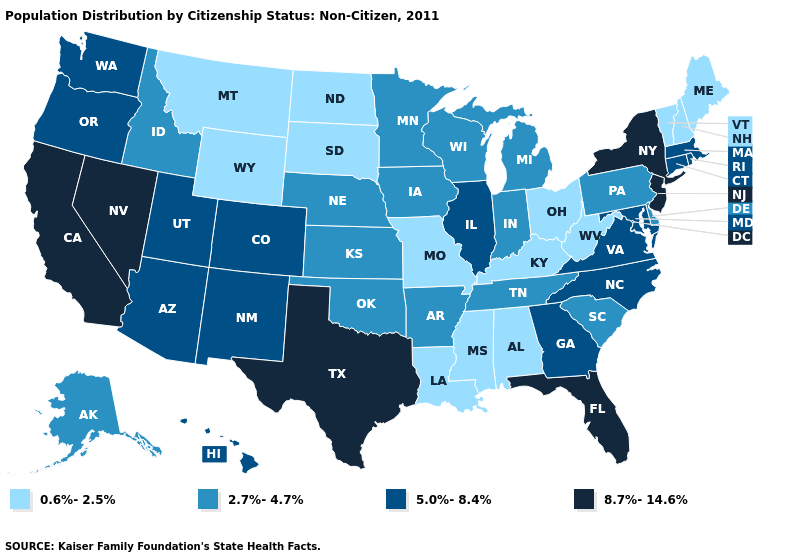Name the states that have a value in the range 5.0%-8.4%?
Quick response, please. Arizona, Colorado, Connecticut, Georgia, Hawaii, Illinois, Maryland, Massachusetts, New Mexico, North Carolina, Oregon, Rhode Island, Utah, Virginia, Washington. What is the value of Iowa?
Quick response, please. 2.7%-4.7%. What is the highest value in states that border Florida?
Give a very brief answer. 5.0%-8.4%. Among the states that border Colorado , which have the highest value?
Keep it brief. Arizona, New Mexico, Utah. Among the states that border Connecticut , which have the highest value?
Give a very brief answer. New York. Does Arizona have a lower value than New Jersey?
Write a very short answer. Yes. How many symbols are there in the legend?
Concise answer only. 4. How many symbols are there in the legend?
Give a very brief answer. 4. Does Oregon have the same value as Iowa?
Quick response, please. No. Is the legend a continuous bar?
Answer briefly. No. Does Montana have the lowest value in the West?
Write a very short answer. Yes. What is the value of Massachusetts?
Keep it brief. 5.0%-8.4%. Does Illinois have the same value as Georgia?
Answer briefly. Yes. Does Missouri have the lowest value in the MidWest?
Give a very brief answer. Yes. Which states hav the highest value in the South?
Short answer required. Florida, Texas. 